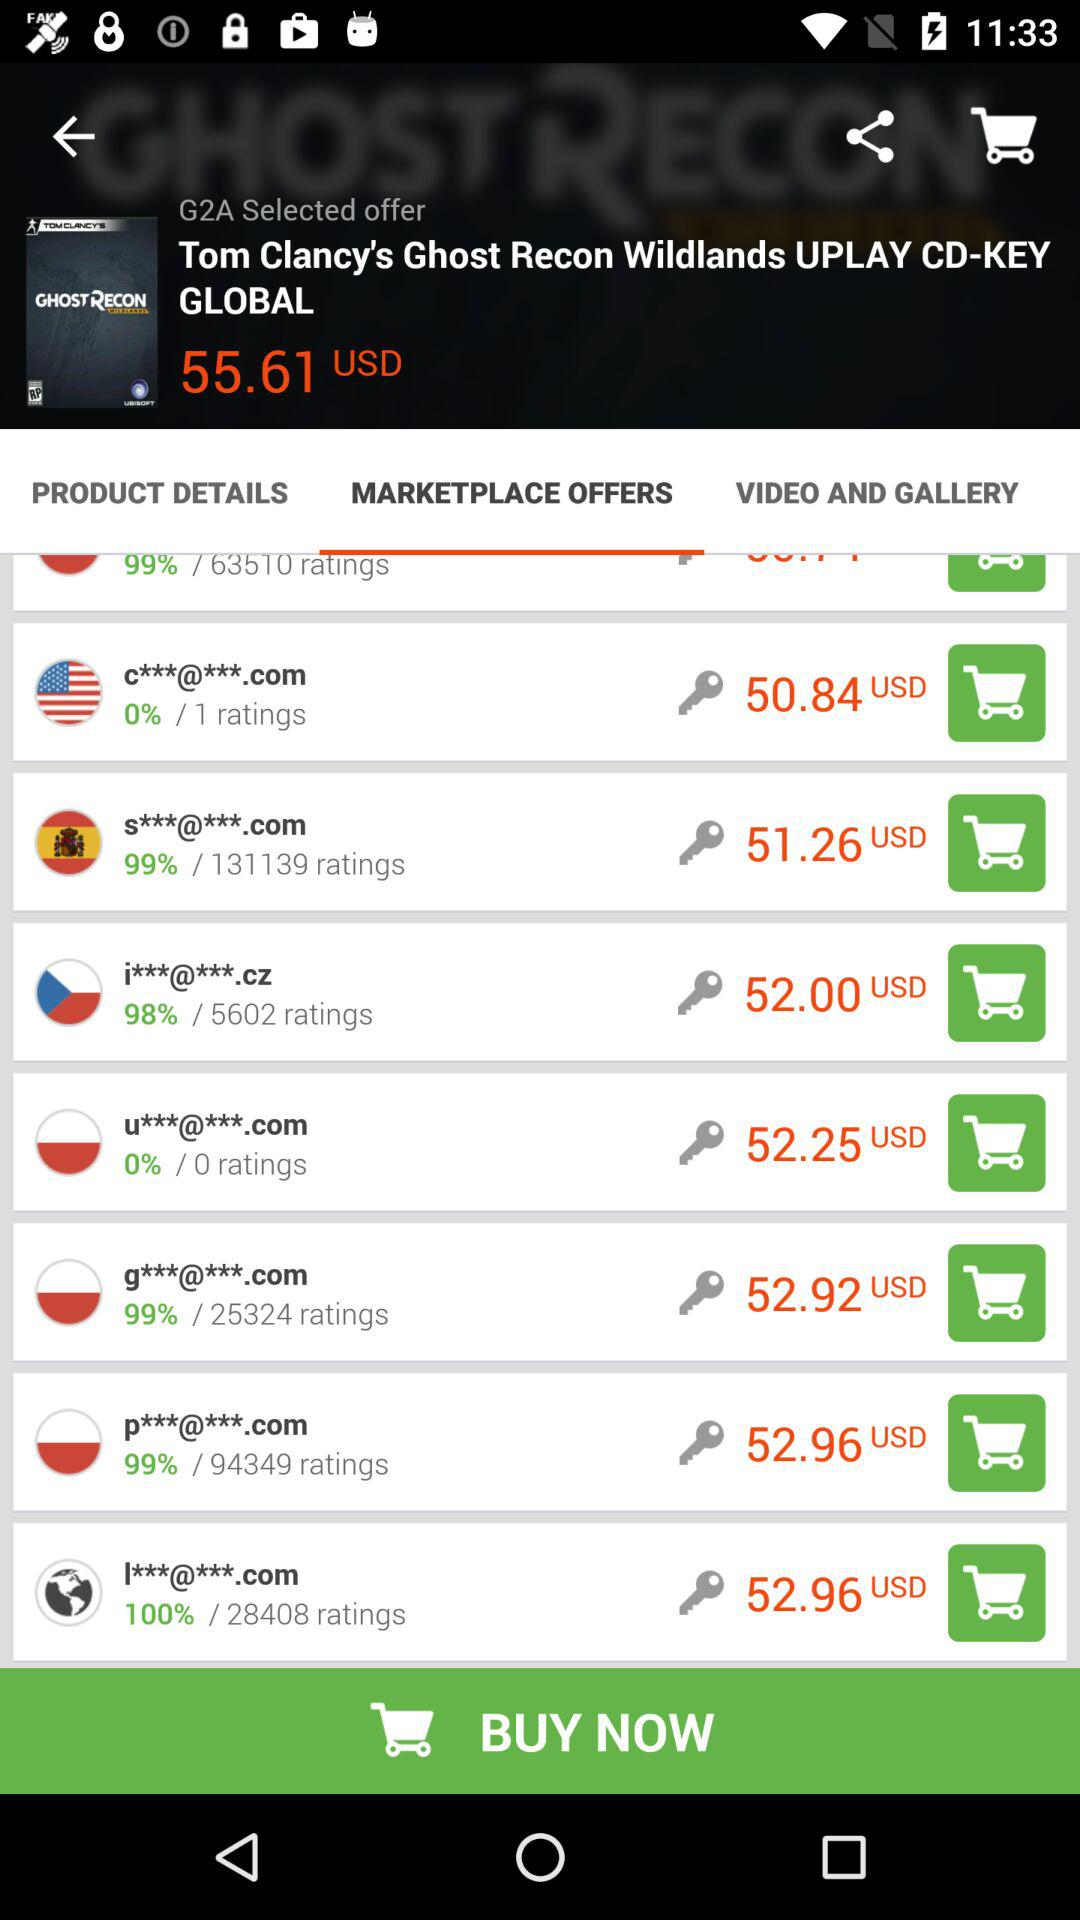What is the price of the "Tom Clancy's Ghost Recon Wildlands UPLAY CD-KEY"? The price is 55.61 USD. 